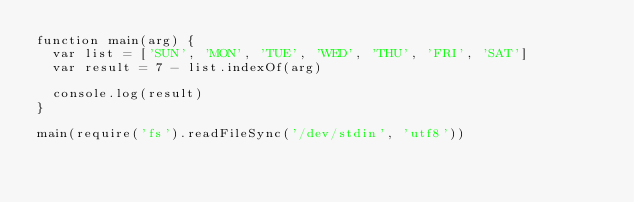<code> <loc_0><loc_0><loc_500><loc_500><_JavaScript_>function main(arg) {
  var list = ['SUN', 'MON', 'TUE', 'WED', 'THU', 'FRI', 'SAT']
  var result = 7 - list.indexOf(arg)

  console.log(result)
}

main(require('fs').readFileSync('/dev/stdin', 'utf8'))</code> 